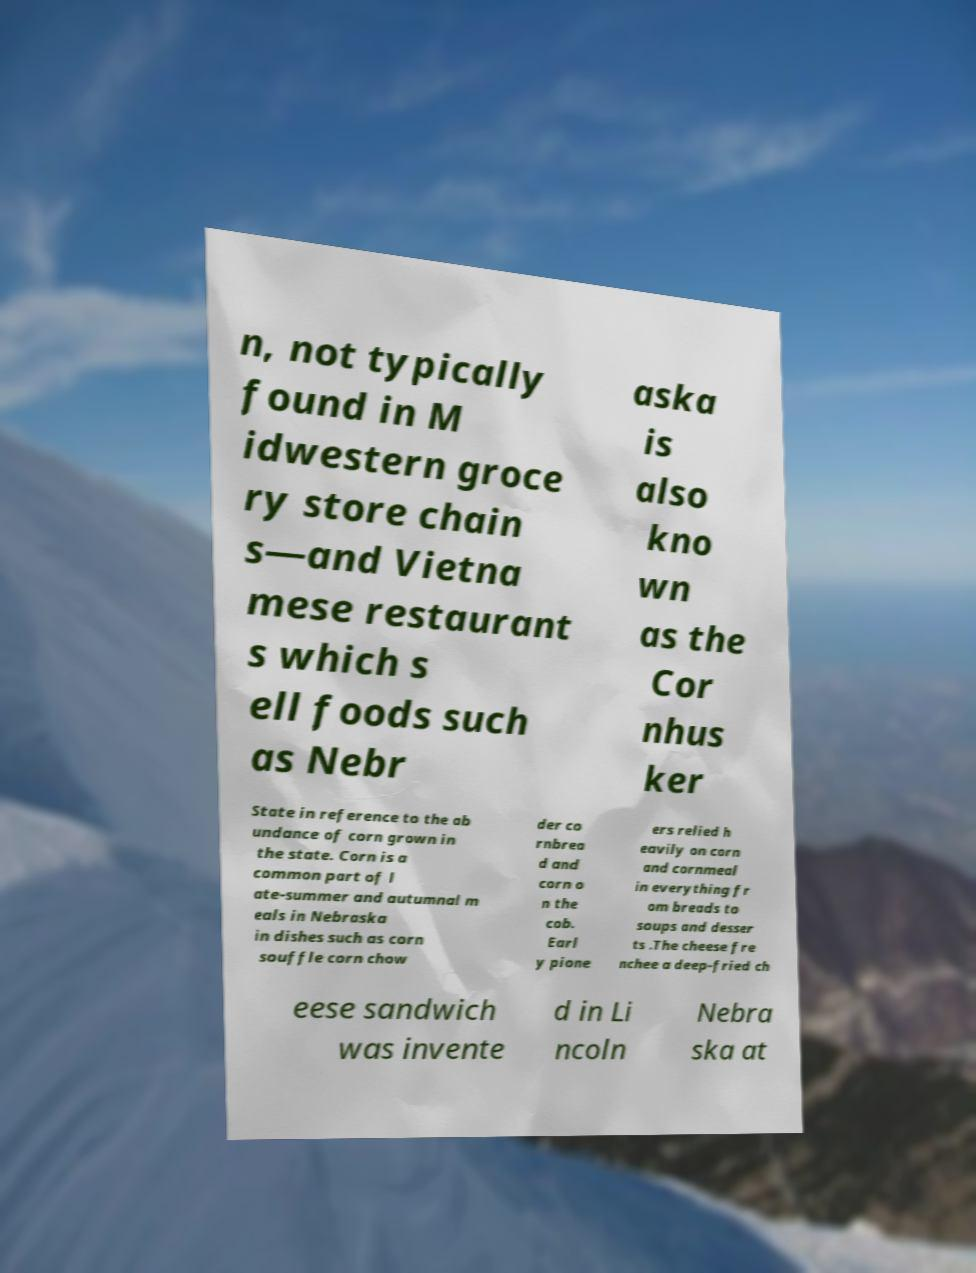What messages or text are displayed in this image? I need them in a readable, typed format. n, not typically found in M idwestern groce ry store chain s—and Vietna mese restaurant s which s ell foods such as Nebr aska is also kno wn as the Cor nhus ker State in reference to the ab undance of corn grown in the state. Corn is a common part of l ate-summer and autumnal m eals in Nebraska in dishes such as corn souffle corn chow der co rnbrea d and corn o n the cob. Earl y pione ers relied h eavily on corn and cornmeal in everything fr om breads to soups and desser ts .The cheese fre nchee a deep-fried ch eese sandwich was invente d in Li ncoln Nebra ska at 